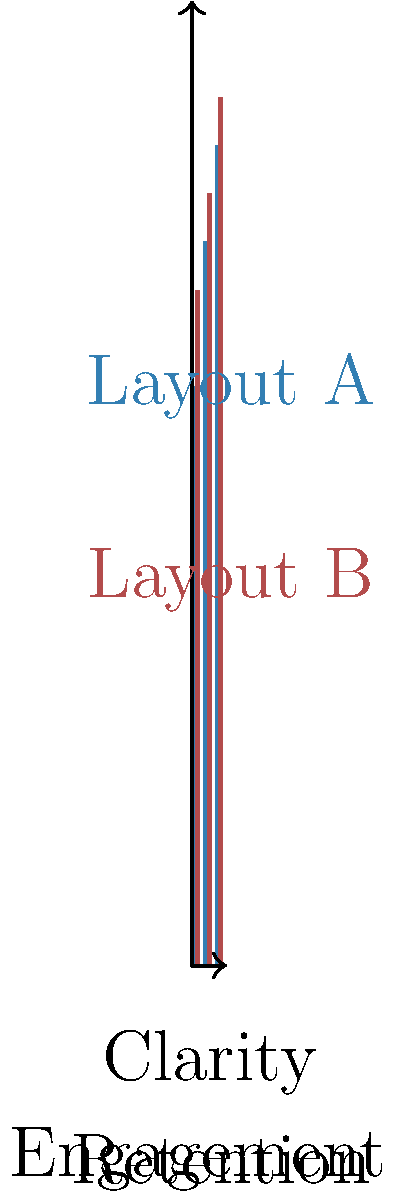Based on the infographic comparing two layout designs (A and B) for presenting marketing data, which layout appears to be more effective overall, and what specific aspect shows the most significant difference between the two layouts? To answer this question, we need to analyze the data presented in the bar chart:

1. The chart compares two layouts (A and B) across three criteria: Clarity, Engagement, and Retention.

2. For each criterion, we'll compare the values:
   a. Clarity: Layout A = 60%, Layout B = 70%
   b. Engagement: Layout A = 75%, Layout B = 80%
   c. Retention: Layout A = 85%, Layout B = 90%

3. Layout B consistently outperforms Layout A in all three criteria.

4. To determine the most significant difference, we'll calculate the difference for each criterion:
   a. Clarity: 70% - 60% = 10%
   b. Engagement: 80% - 75% = 5%
   c. Retention: 90% - 85% = 5%

5. The largest difference is in the Clarity criterion, with a 10% gap between Layout A and Layout B.

Therefore, Layout B appears to be more effective overall, as it scores higher in all three criteria. The most significant difference between the two layouts is in the Clarity aspect, with a 10% difference favoring Layout B.
Answer: Layout B; Clarity (10% difference) 